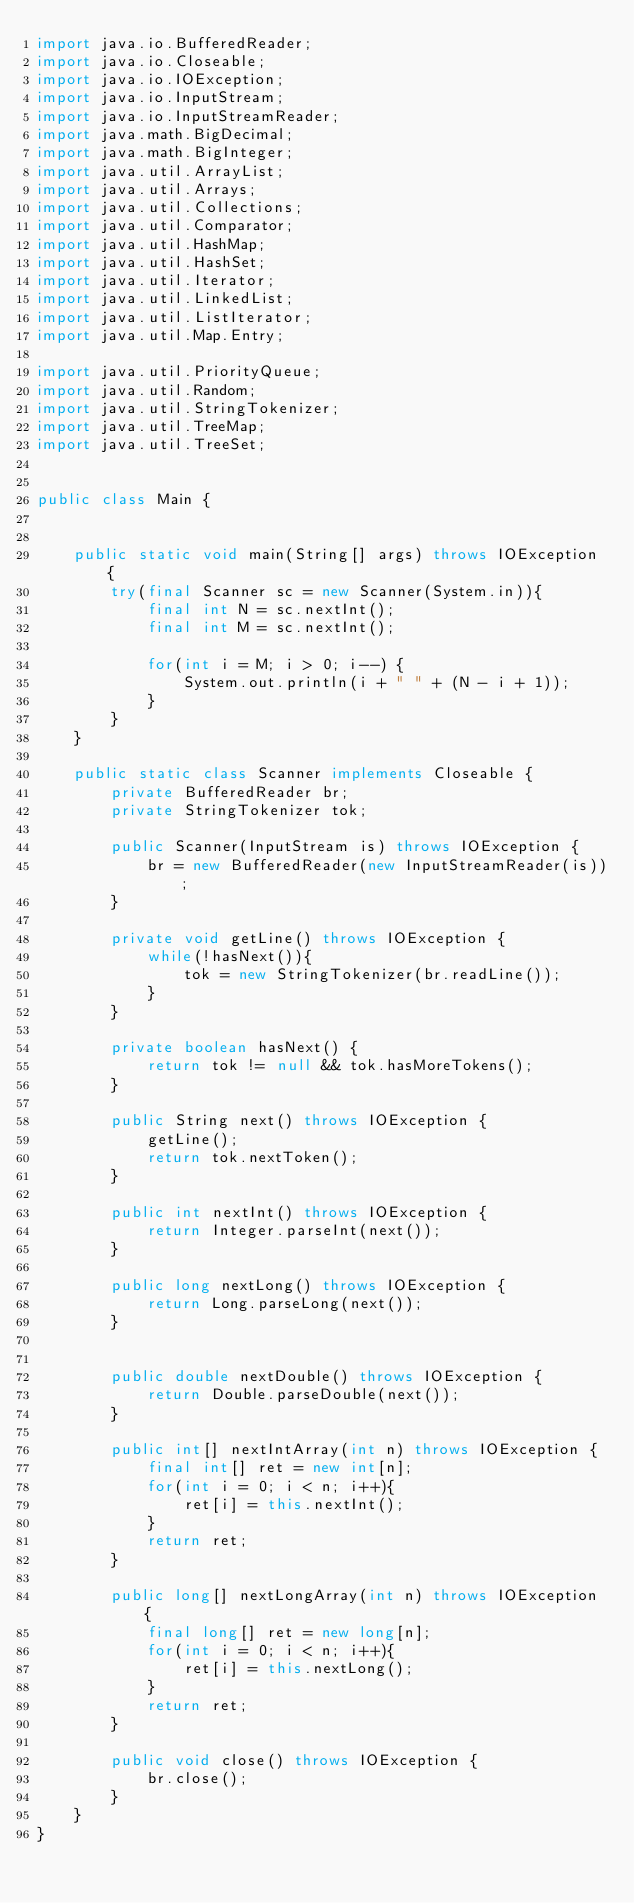Convert code to text. <code><loc_0><loc_0><loc_500><loc_500><_Java_>import java.io.BufferedReader;
import java.io.Closeable;
import java.io.IOException;
import java.io.InputStream;
import java.io.InputStreamReader;
import java.math.BigDecimal;
import java.math.BigInteger;
import java.util.ArrayList;
import java.util.Arrays;
import java.util.Collections;
import java.util.Comparator;
import java.util.HashMap;
import java.util.HashSet;
import java.util.Iterator;
import java.util.LinkedList;
import java.util.ListIterator;
import java.util.Map.Entry;

import java.util.PriorityQueue;
import java.util.Random;
import java.util.StringTokenizer;
import java.util.TreeMap;
import java.util.TreeSet;


public class Main {
	
	
	public static void main(String[] args) throws IOException {	
		try(final Scanner sc = new Scanner(System.in)){
			final int N = sc.nextInt();
			final int M = sc.nextInt();
			
			for(int i = M; i > 0; i--) {
				System.out.println(i + " " + (N - i + 1));
			}
		}
	}

	public static class Scanner implements Closeable {
		private BufferedReader br;
		private StringTokenizer tok;

		public Scanner(InputStream is) throws IOException {
			br = new BufferedReader(new InputStreamReader(is));
		}

		private void getLine() throws IOException {
			while(!hasNext()){
				tok = new StringTokenizer(br.readLine());
			}
		}

		private boolean hasNext() {
			return tok != null && tok.hasMoreTokens();
		}

		public String next() throws IOException {
			getLine();
			return tok.nextToken();
		}

		public int nextInt() throws IOException {
			return Integer.parseInt(next());
		}

		public long nextLong() throws IOException {
			return Long.parseLong(next());
		}
		

		public double nextDouble() throws IOException {
			return Double.parseDouble(next());
		}

		public int[] nextIntArray(int n) throws IOException {
			final int[] ret = new int[n];
			for(int i = 0; i < n; i++){
				ret[i] = this.nextInt();
			}
			return ret;
		}

		public long[] nextLongArray(int n) throws IOException {
			final long[] ret = new long[n];
			for(int i = 0; i < n; i++){
				ret[i] = this.nextLong();
			}
			return ret;
		}

		public void close() throws IOException {
			br.close();
		}
	}
}
</code> 